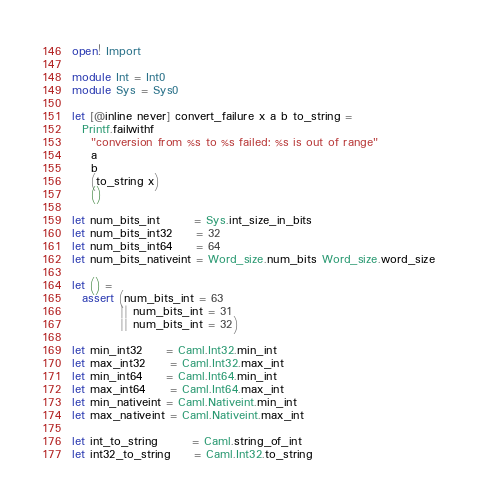<code> <loc_0><loc_0><loc_500><loc_500><_OCaml_>open! Import

module Int = Int0
module Sys = Sys0

let [@inline never] convert_failure x a b to_string =
  Printf.failwithf
    "conversion from %s to %s failed: %s is out of range"
    a
    b
    (to_string x)
    ()

let num_bits_int       = Sys.int_size_in_bits
let num_bits_int32     = 32
let num_bits_int64     = 64
let num_bits_nativeint = Word_size.num_bits Word_size.word_size

let () =
  assert (num_bits_int = 63
          || num_bits_int = 31
          || num_bits_int = 32)

let min_int32     = Caml.Int32.min_int
let max_int32     = Caml.Int32.max_int
let min_int64     = Caml.Int64.min_int
let max_int64     = Caml.Int64.max_int
let min_nativeint = Caml.Nativeint.min_int
let max_nativeint = Caml.Nativeint.max_int

let int_to_string       = Caml.string_of_int
let int32_to_string     = Caml.Int32.to_string</code> 